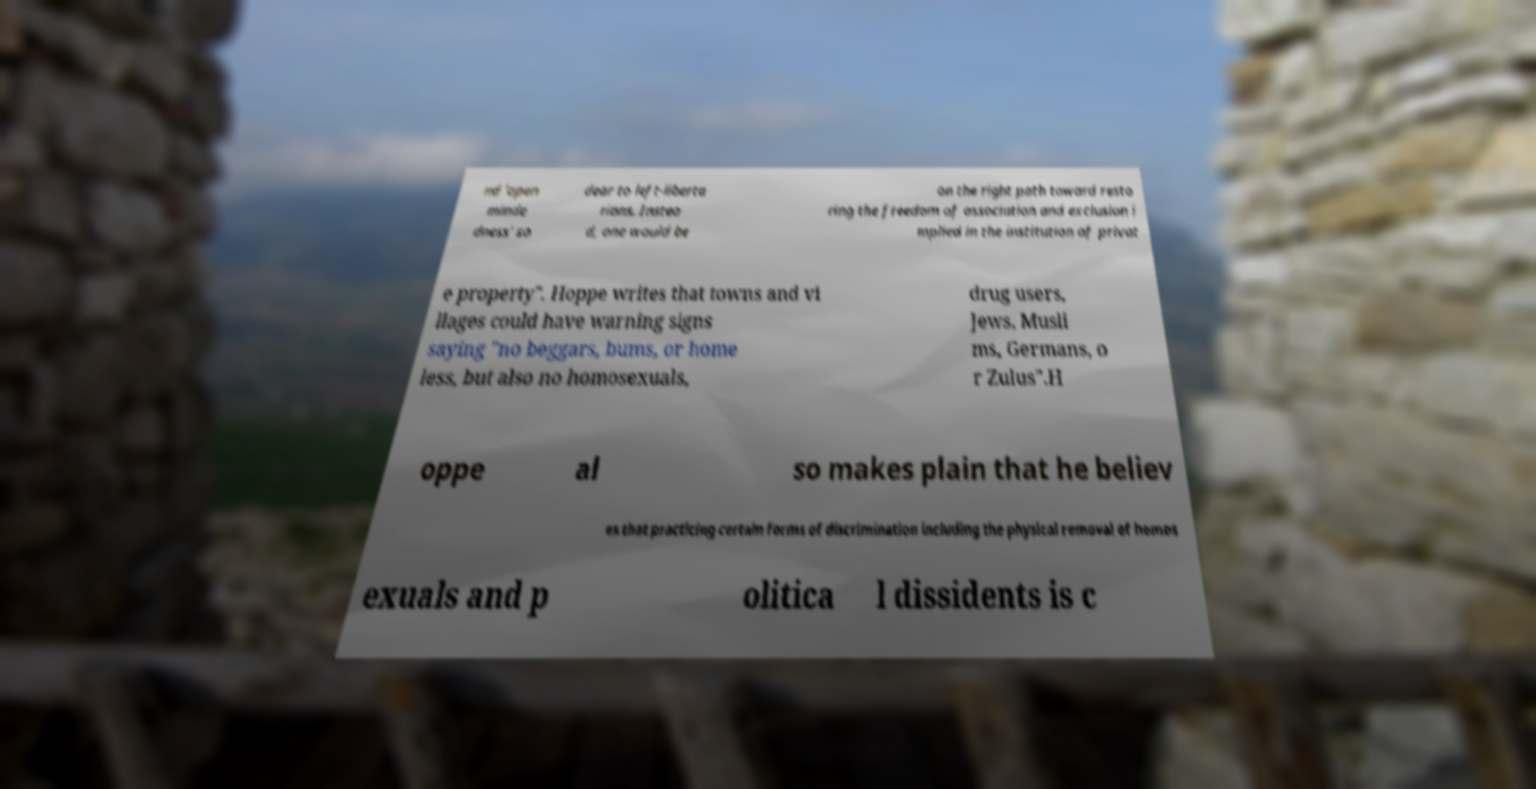For documentation purposes, I need the text within this image transcribed. Could you provide that? nd 'open minde dness' so dear to left-liberta rians. Instea d, one would be on the right path toward resto ring the freedom of association and exclusion i mplied in the institution of privat e property". Hoppe writes that towns and vi llages could have warning signs saying "no beggars, bums, or home less, but also no homosexuals, drug users, Jews, Musli ms, Germans, o r Zulus".H oppe al so makes plain that he believ es that practicing certain forms of discrimination including the physical removal of homos exuals and p olitica l dissidents is c 